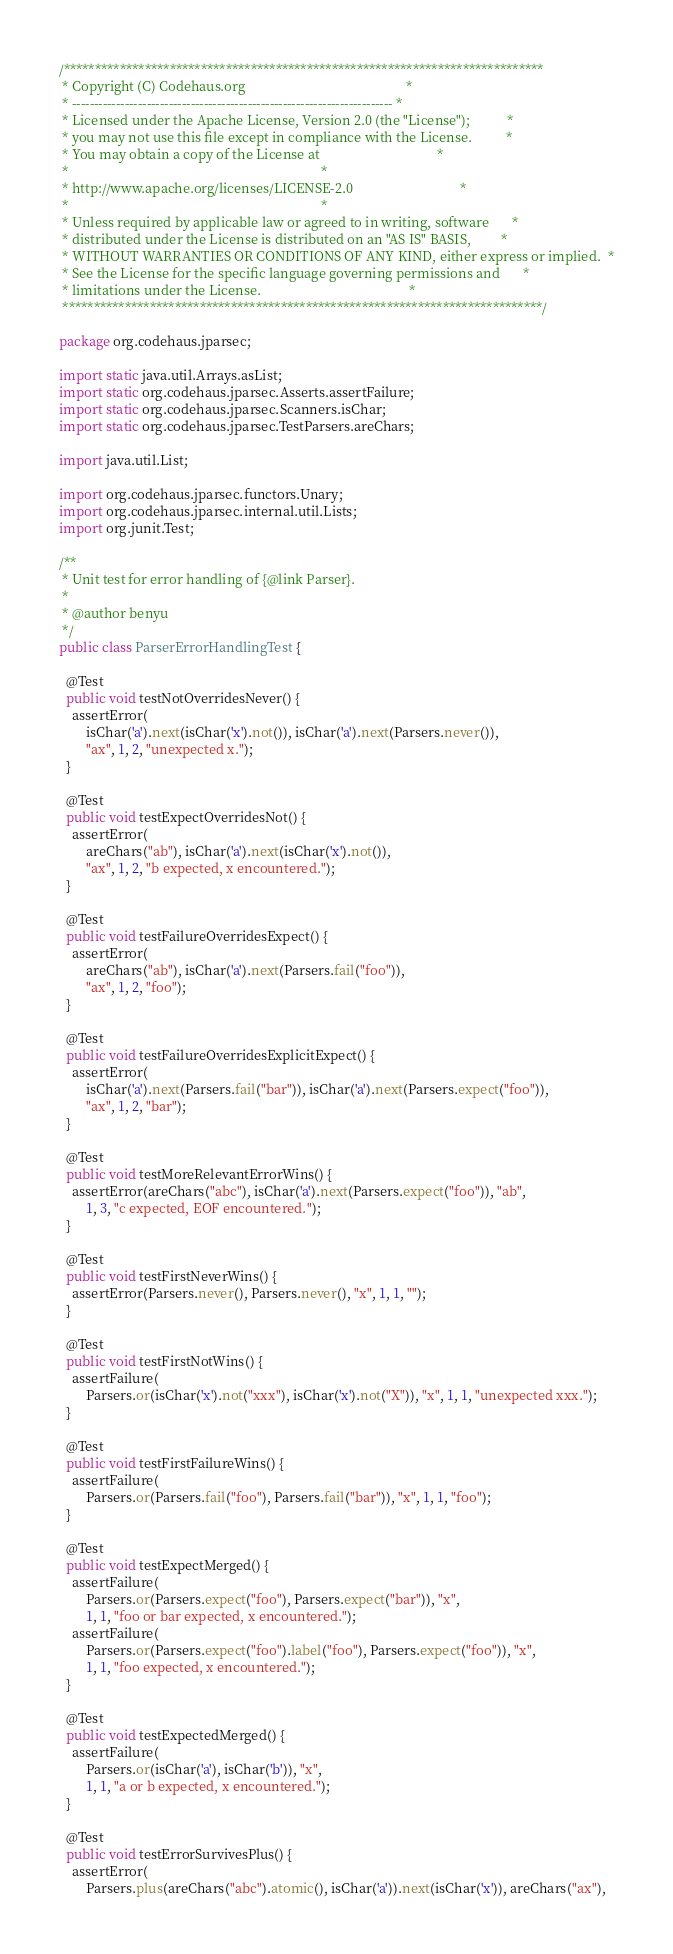Convert code to text. <code><loc_0><loc_0><loc_500><loc_500><_Java_>/*****************************************************************************
 * Copyright (C) Codehaus.org                                                *
 * ------------------------------------------------------------------------- *
 * Licensed under the Apache License, Version 2.0 (the "License");           *
 * you may not use this file except in compliance with the License.          *
 * You may obtain a copy of the License at                                   *
 *                                                                           *
 * http://www.apache.org/licenses/LICENSE-2.0                                *
 *                                                                           *
 * Unless required by applicable law or agreed to in writing, software       *
 * distributed under the License is distributed on an "AS IS" BASIS,         *
 * WITHOUT WARRANTIES OR CONDITIONS OF ANY KIND, either express or implied.  *
 * See the License for the specific language governing permissions and       *
 * limitations under the License.                                            *
 *****************************************************************************/

package org.codehaus.jparsec;

import static java.util.Arrays.asList;
import static org.codehaus.jparsec.Asserts.assertFailure;
import static org.codehaus.jparsec.Scanners.isChar;
import static org.codehaus.jparsec.TestParsers.areChars;

import java.util.List;

import org.codehaus.jparsec.functors.Unary;
import org.codehaus.jparsec.internal.util.Lists;
import org.junit.Test;

/**
 * Unit test for error handling of {@link Parser}.
 * 
 * @author benyu
 */
public class ParserErrorHandlingTest {

  @Test
  public void testNotOverridesNever() {
    assertError(
        isChar('a').next(isChar('x').not()), isChar('a').next(Parsers.never()),
        "ax", 1, 2, "unexpected x.");
  }

  @Test
  public void testExpectOverridesNot() {
    assertError(
        areChars("ab"), isChar('a').next(isChar('x').not()),
        "ax", 1, 2, "b expected, x encountered.");
  }

  @Test
  public void testFailureOverridesExpect() {
    assertError(
        areChars("ab"), isChar('a').next(Parsers.fail("foo")),
        "ax", 1, 2, "foo");
  }

  @Test
  public void testFailureOverridesExplicitExpect() {
    assertError(
        isChar('a').next(Parsers.fail("bar")), isChar('a').next(Parsers.expect("foo")),
        "ax", 1, 2, "bar");
  }

  @Test
  public void testMoreRelevantErrorWins() {
    assertError(areChars("abc"), isChar('a').next(Parsers.expect("foo")), "ab",
        1, 3, "c expected, EOF encountered.");
  }

  @Test
  public void testFirstNeverWins() {
    assertError(Parsers.never(), Parsers.never(), "x", 1, 1, "");
  }

  @Test
  public void testFirstNotWins() {
    assertFailure(
        Parsers.or(isChar('x').not("xxx"), isChar('x').not("X")), "x", 1, 1, "unexpected xxx.");
  }

  @Test
  public void testFirstFailureWins() {
    assertFailure(
        Parsers.or(Parsers.fail("foo"), Parsers.fail("bar")), "x", 1, 1, "foo");
  }

  @Test
  public void testExpectMerged() {
    assertFailure(
        Parsers.or(Parsers.expect("foo"), Parsers.expect("bar")), "x",
        1, 1, "foo or bar expected, x encountered.");
    assertFailure(
        Parsers.or(Parsers.expect("foo").label("foo"), Parsers.expect("foo")), "x",
        1, 1, "foo expected, x encountered.");
  }

  @Test
  public void testExpectedMerged() {
    assertFailure(
        Parsers.or(isChar('a'), isChar('b')), "x",
        1, 1, "a or b expected, x encountered.");
  }

  @Test
  public void testErrorSurvivesPlus() {
    assertError(
        Parsers.plus(areChars("abc").atomic(), isChar('a')).next(isChar('x')), areChars("ax"),</code> 